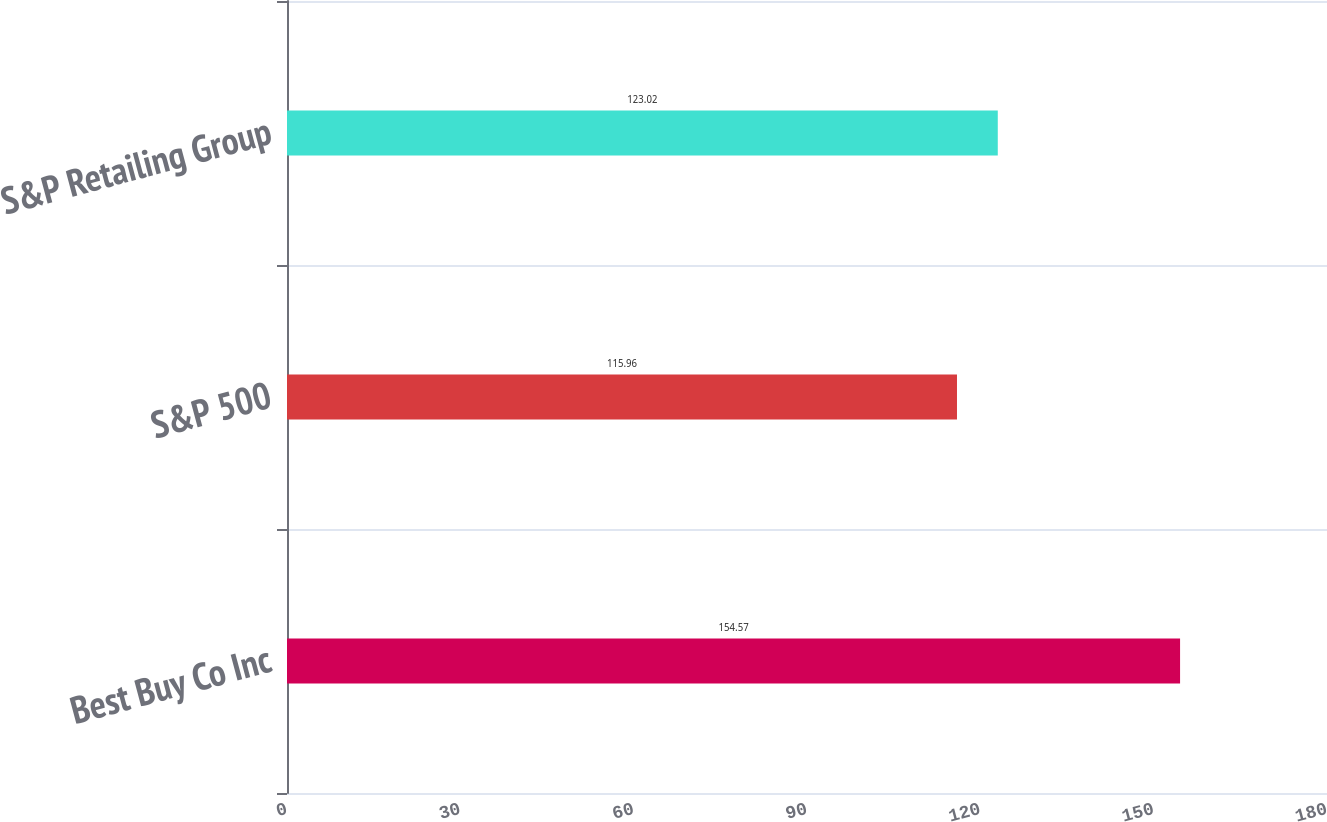Convert chart to OTSL. <chart><loc_0><loc_0><loc_500><loc_500><bar_chart><fcel>Best Buy Co Inc<fcel>S&P 500<fcel>S&P Retailing Group<nl><fcel>154.57<fcel>115.96<fcel>123.02<nl></chart> 